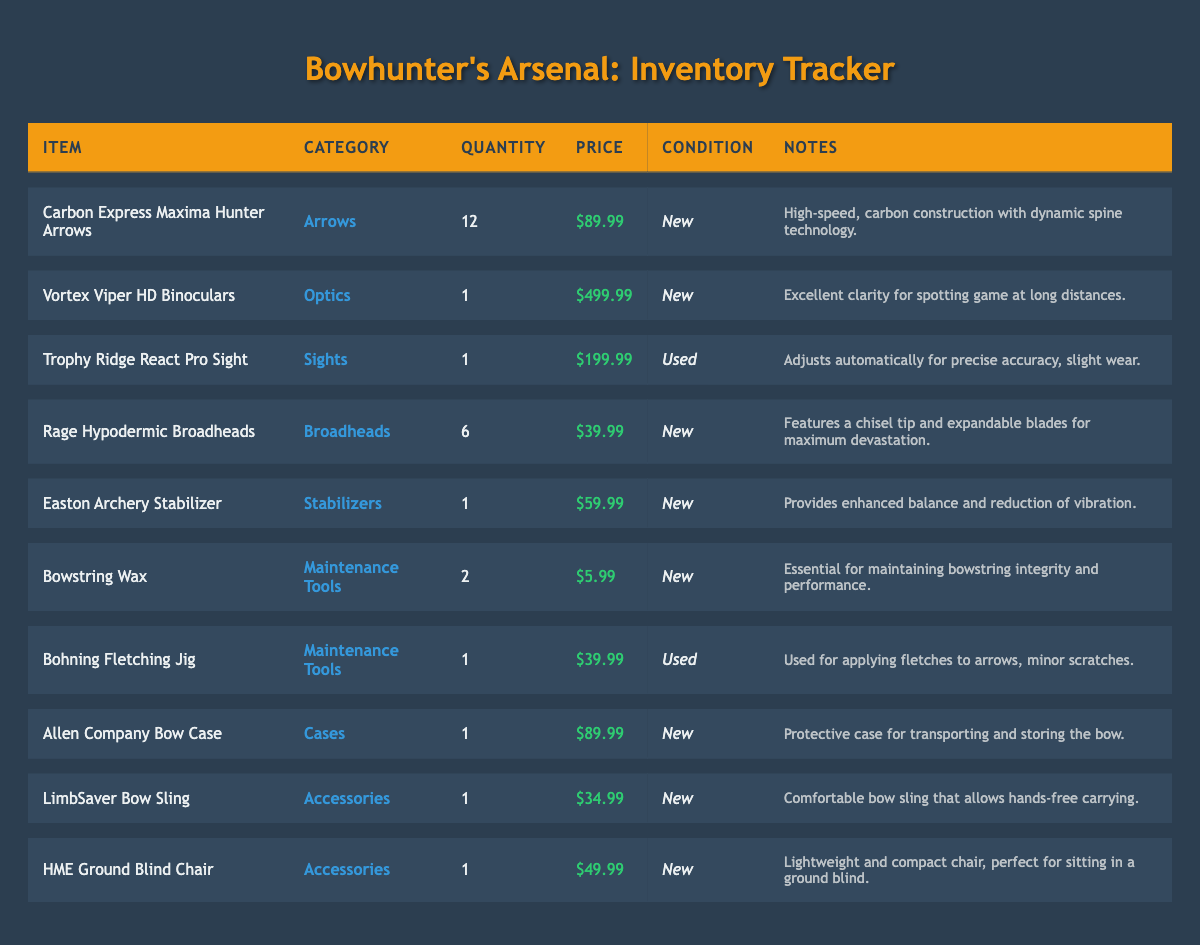What is the total quantity of arrows in the inventory? There is only one item categorized as "Arrows," which is the "Carbon Express Maxima Hunter Arrows," with a quantity of 12.
Answer: 12 What is the condition of the Vortex Viper HD Binoculars? Checking the row for "Vortex Viper HD Binoculars," we find that the condition is listed as "New."
Answer: New Are there any used items in the inventory? Looking through the "Condition" column, there is one item, the "Trophy Ridge React Pro Sight," that is noted as "Used."
Answer: Yes What is the price of the Rage Hypodermic Broadheads? The row for the "Rage Hypodermic Broadheads" indicates a price of $39.99.
Answer: $39.99 What is the average price of the items in the "Maintenance Tools" category? The items in this category are "Bowstring Wax" priced at $5.99 and "Bohning Fletching Jig" priced at $39.99. Adding these prices gives $5.99 + $39.99 = $45.98. Then, dividing by the number of items (2) gives us an average price of $45.98 / 2 = $22.99.
Answer: $22.99 Which category has the highest-priced item, and what is the item? Upon examining the table, "Vortex Viper HD Binoculars" in the "Optics" category has the highest price of $499.99, which is greater than all other items listed.
Answer: Optics, Vortex Viper HD Binoculars How many items in the inventory are categorized as "Accessories"? There are two items under the "Accessories" category: "LimbSaver Bow Sling" and "HME Ground Blind Chair." Counting these gives a total of 2 items.
Answer: 2 Is the Allen Company Bow Case condition listed as used? The condition for the "Allen Company Bow Case" is specified as "New" in its respective row, confirming that it is not used.
Answer: No What is the total price of all "Sights" items in the inventory? The only item under "Sights" is the "Trophy Ridge React Pro Sight," priced at $199.99. Therefore, the total price for "Sights" items is simply $199.99 as there is only one item.
Answer: $199.99 